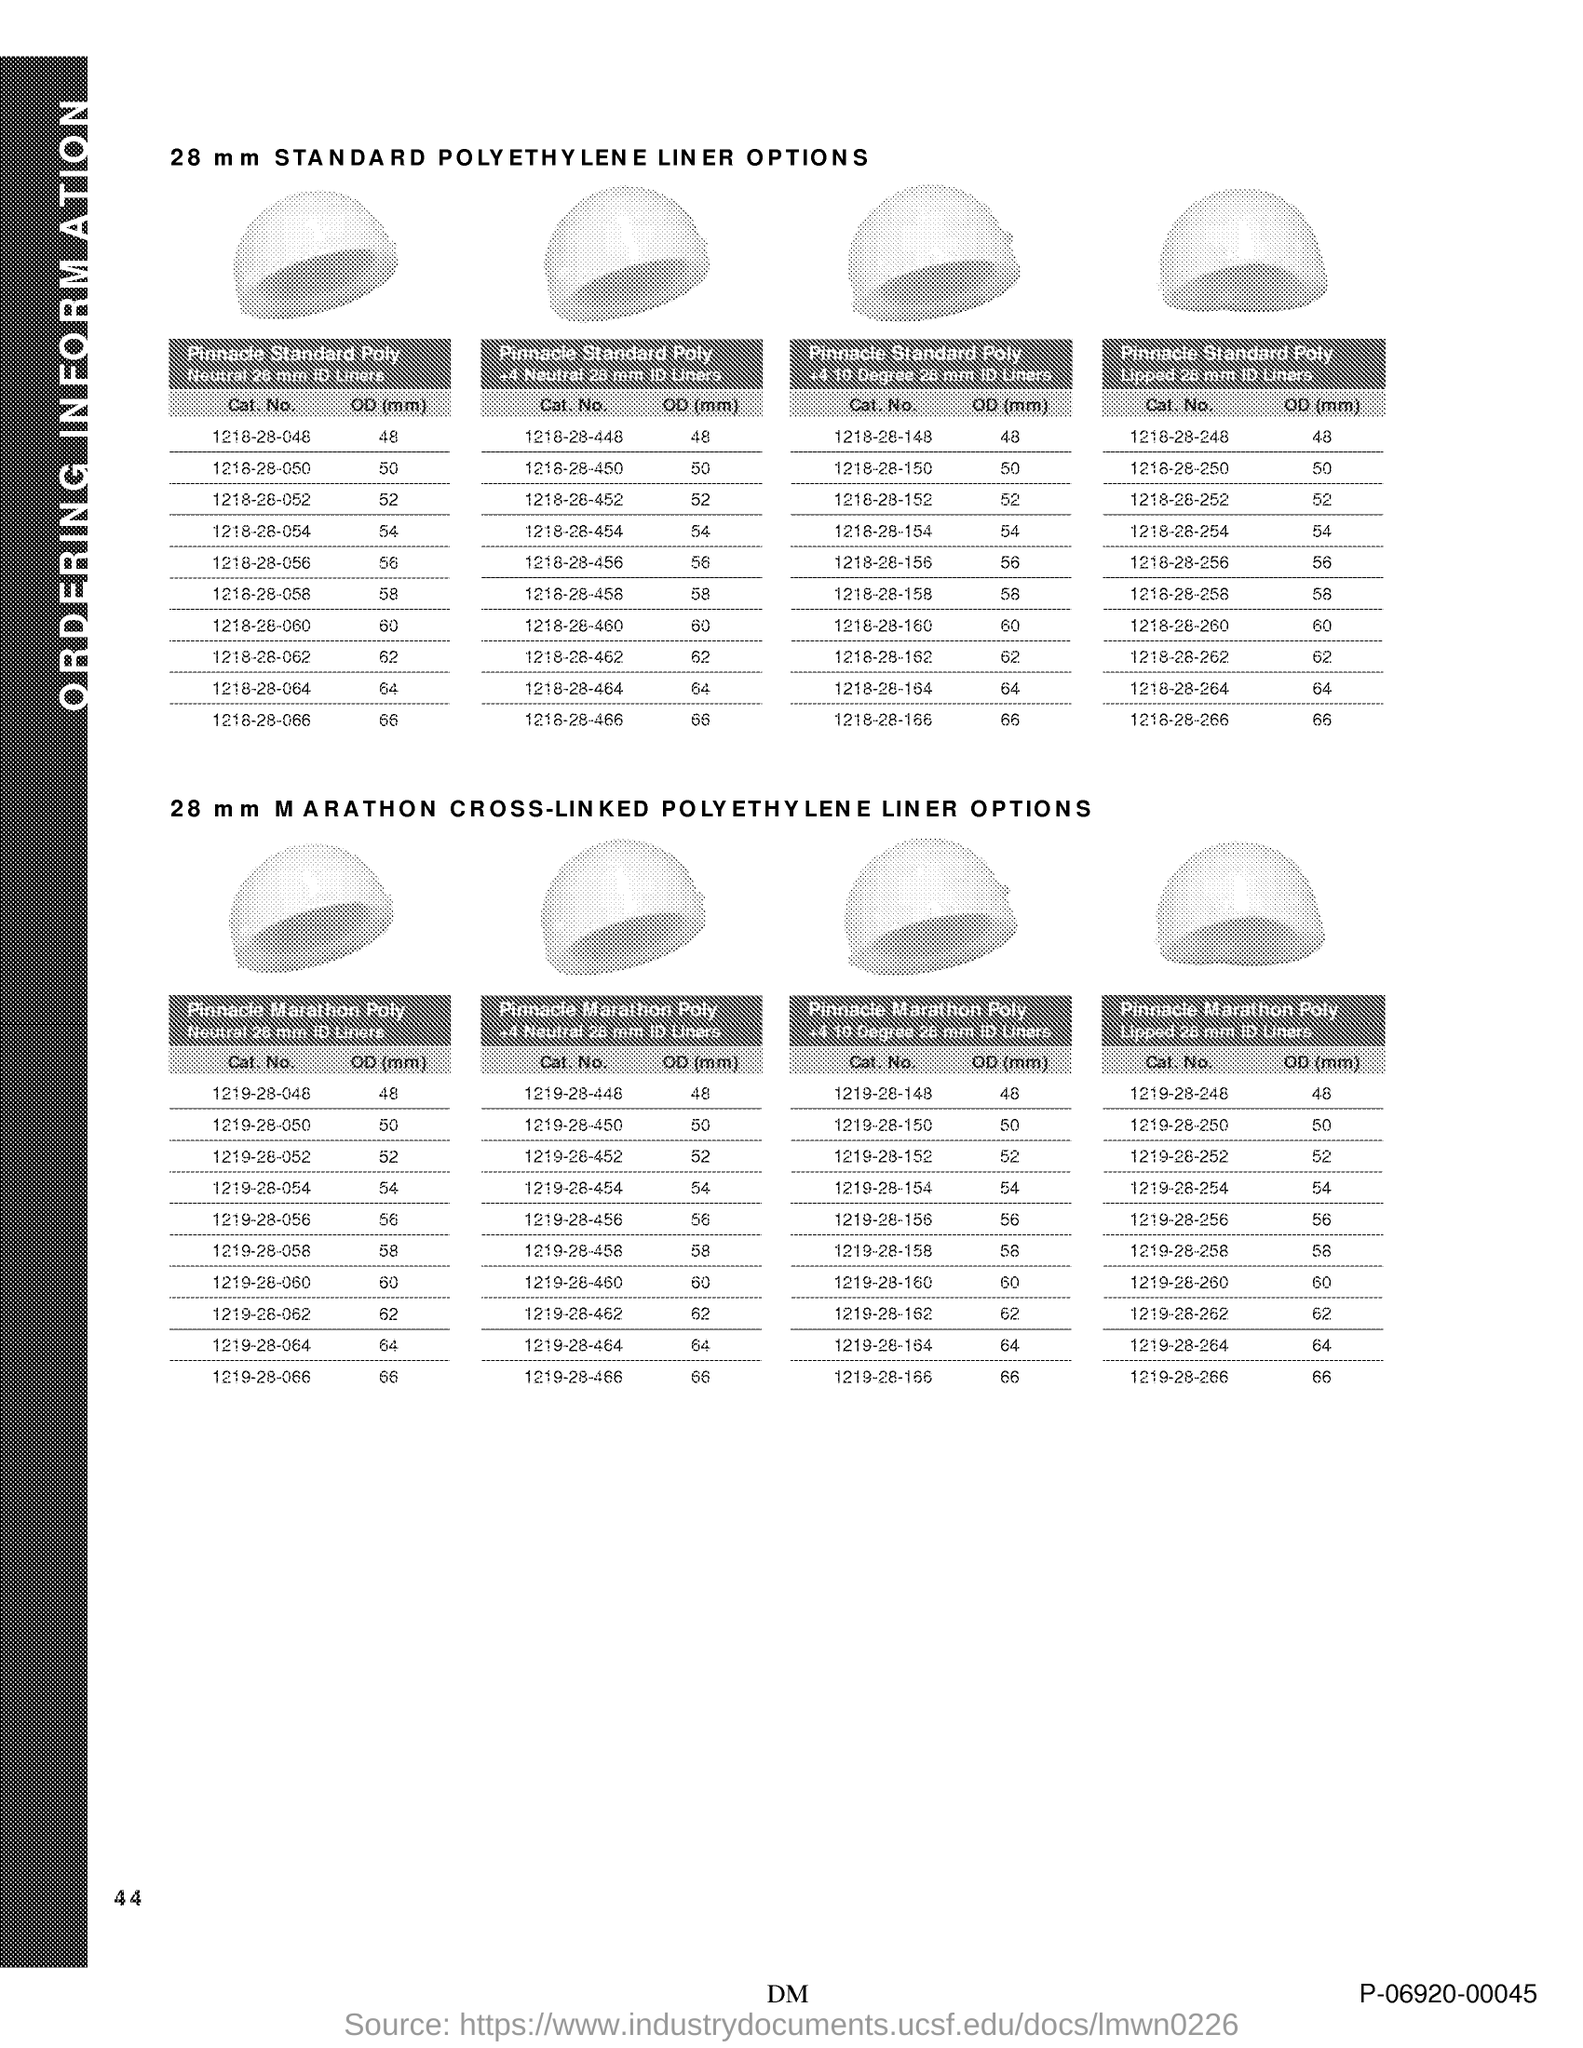Specify some key components in this picture. The page number is 44. 